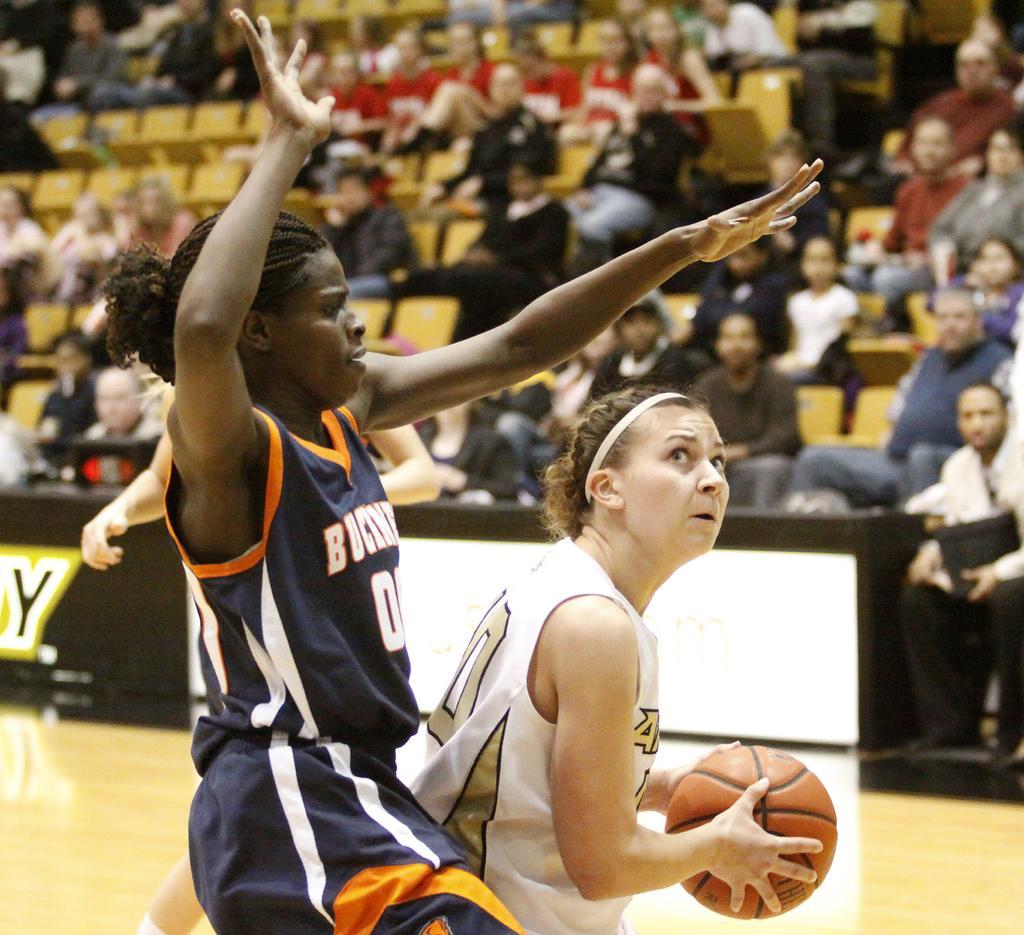Can you describe this image briefly? In this picture we can see two women are playing basketball game, a woman on the right side is holding a ball, in the background there are some people sitting on chairs. 